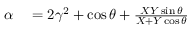Convert formula to latex. <formula><loc_0><loc_0><loc_500><loc_500>\begin{array} { r l } { \alpha } & = 2 \gamma ^ { 2 } + \cos \theta + \frac { X Y \sin \theta } { X + Y \cos \theta } } \end{array}</formula> 